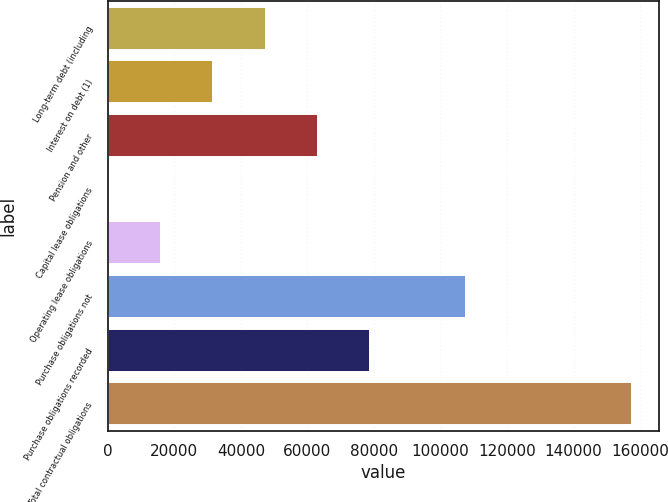Convert chart to OTSL. <chart><loc_0><loc_0><loc_500><loc_500><bar_chart><fcel>Long-term debt (including<fcel>Interest on debt (1)<fcel>Pension and other<fcel>Capital lease obligations<fcel>Operating lease obligations<fcel>Purchase obligations not<fcel>Purchase obligations recorded<fcel>Total contractual obligations<nl><fcel>47409<fcel>31654<fcel>63164<fcel>144<fcel>15899<fcel>107564<fcel>78919<fcel>157694<nl></chart> 